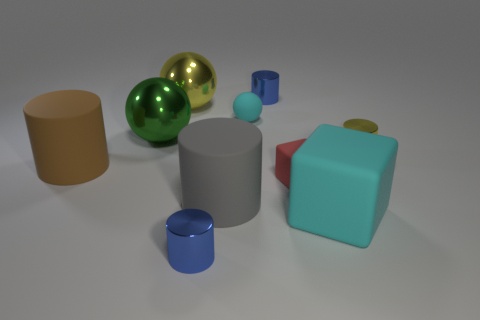Subtract all yellow cylinders. How many cylinders are left? 4 Subtract all big brown cylinders. How many cylinders are left? 4 Subtract 2 cylinders. How many cylinders are left? 3 Subtract all red cylinders. Subtract all red blocks. How many cylinders are left? 5 Subtract all cubes. How many objects are left? 8 Subtract all small matte balls. Subtract all big rubber cubes. How many objects are left? 8 Add 4 cyan balls. How many cyan balls are left? 5 Add 4 tiny purple metal cylinders. How many tiny purple metal cylinders exist? 4 Subtract 0 yellow blocks. How many objects are left? 10 